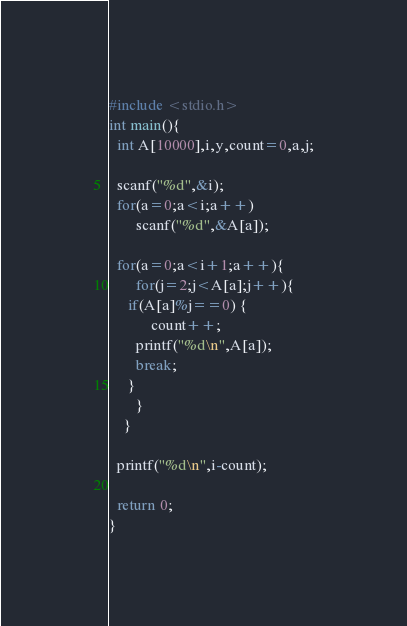<code> <loc_0><loc_0><loc_500><loc_500><_C_>#include <stdio.h>
int main(){
  int A[10000],i,y,count=0,a,j;

  scanf("%d",&i);
  for(a=0;a<i;a++)
       scanf("%d",&A[a]);

  for(a=0;a<i+1;a++){
       for(j=2;j<A[a];j++){
	 if(A[a]%j==0) {
           count++;
	   printf("%d\n",A[a]);
	   break;
	 }
       }
    }
  
  printf("%d\n",i-count);

  return 0;
}

</code> 